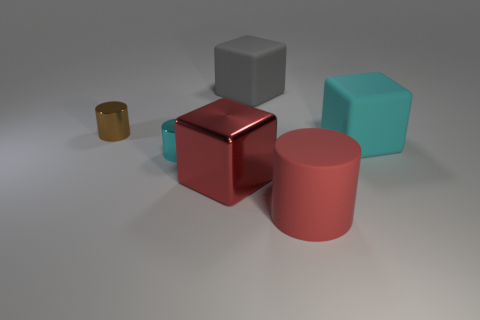Subtract all tiny cyan metallic cylinders. How many cylinders are left? 2 Subtract all gray cubes. How many cubes are left? 2 Add 2 tiny cyan matte cylinders. How many objects exist? 8 Subtract 1 blocks. How many blocks are left? 2 Subtract all large cyan matte spheres. Subtract all cyan shiny cylinders. How many objects are left? 5 Add 1 large cyan rubber things. How many large cyan rubber things are left? 2 Add 1 brown shiny cylinders. How many brown shiny cylinders exist? 2 Subtract 0 gray cylinders. How many objects are left? 6 Subtract all red cylinders. Subtract all red cubes. How many cylinders are left? 2 Subtract all brown blocks. How many brown cylinders are left? 1 